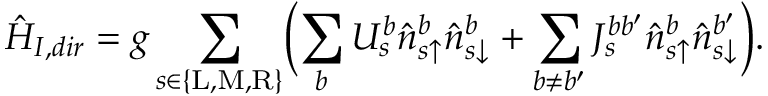Convert formula to latex. <formula><loc_0><loc_0><loc_500><loc_500>\hat { H } _ { I , d i r } = g \sum _ { s \in \{ L , M , R \} } \left ( \sum _ { b } U _ { s } ^ { b } \hat { n } _ { s \uparrow } ^ { b } \hat { n } _ { s \downarrow } ^ { b } + \sum _ { b \neq b ^ { \prime } } J _ { s } ^ { b b ^ { \prime } } \hat { n } _ { s \uparrow } ^ { b } \hat { n } _ { s \downarrow } ^ { b ^ { \prime } } \right ) .</formula> 